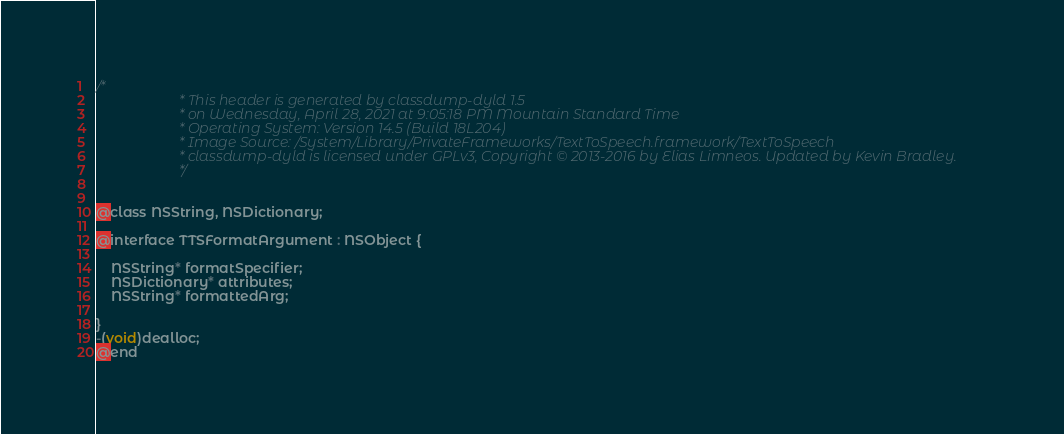Convert code to text. <code><loc_0><loc_0><loc_500><loc_500><_C_>/*
                       * This header is generated by classdump-dyld 1.5
                       * on Wednesday, April 28, 2021 at 9:05:18 PM Mountain Standard Time
                       * Operating System: Version 14.5 (Build 18L204)
                       * Image Source: /System/Library/PrivateFrameworks/TextToSpeech.framework/TextToSpeech
                       * classdump-dyld is licensed under GPLv3, Copyright © 2013-2016 by Elias Limneos. Updated by Kevin Bradley.
                       */


@class NSString, NSDictionary;

@interface TTSFormatArgument : NSObject {

	NSString* formatSpecifier;
	NSDictionary* attributes;
	NSString* formattedArg;

}
-(void)dealloc;
@end

</code> 